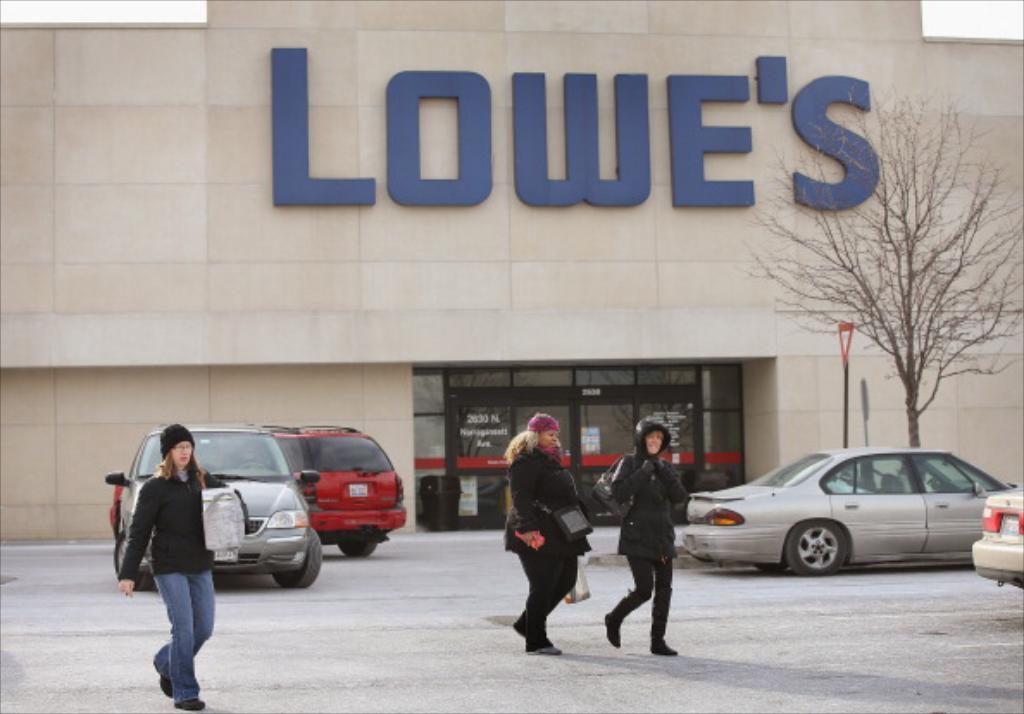Could you give a brief overview of what you see in this image? In this picture I can observe three members walking on the road. I can observe some cars parked on the road behind them. On the right side there is a tree. In the background I can observe a building and some text on the building. 